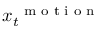Convert formula to latex. <formula><loc_0><loc_0><loc_500><loc_500>\boldsymbol x _ { t } ^ { m o t i o n }</formula> 